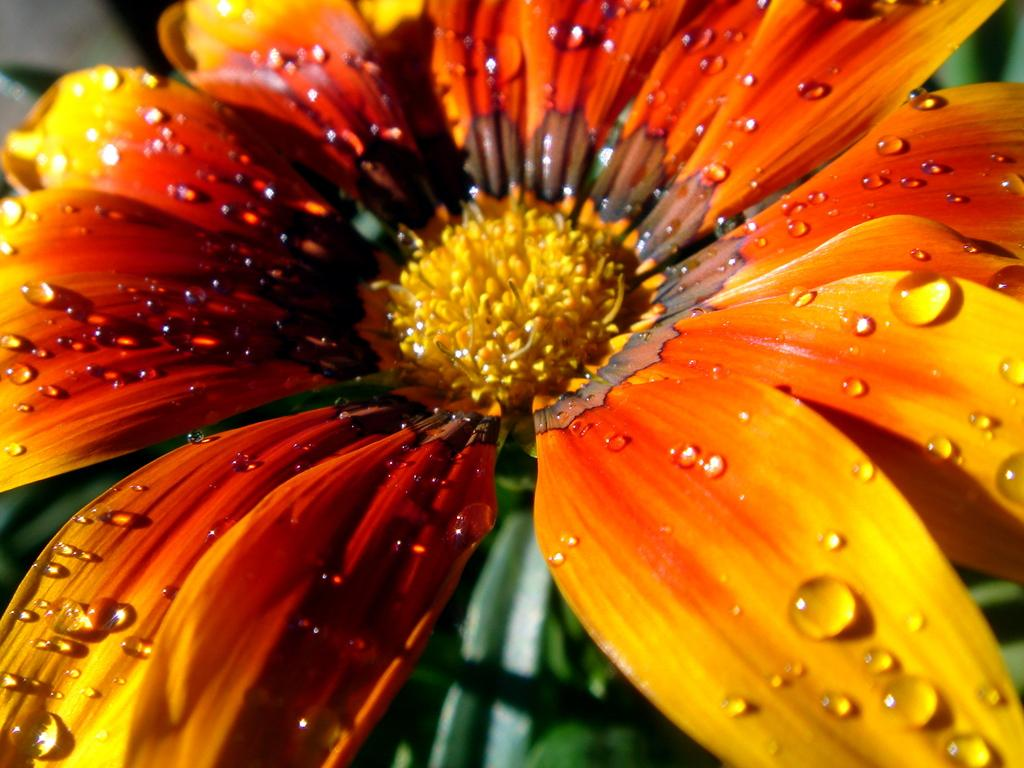What is the main subject of the image? There is a flower in the image. Can you describe the flower in more detail? The flower has water droplets on it. What else can be seen in the background of the image? There are leaves visible in the background of the image. How many nuts are hanging from the flower in the image? There are no nuts present in the image; it features a flower with water droplets and leaves in the background. 